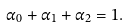Convert formula to latex. <formula><loc_0><loc_0><loc_500><loc_500>\alpha _ { 0 } + \alpha _ { 1 } + \alpha _ { 2 } = 1 .</formula> 